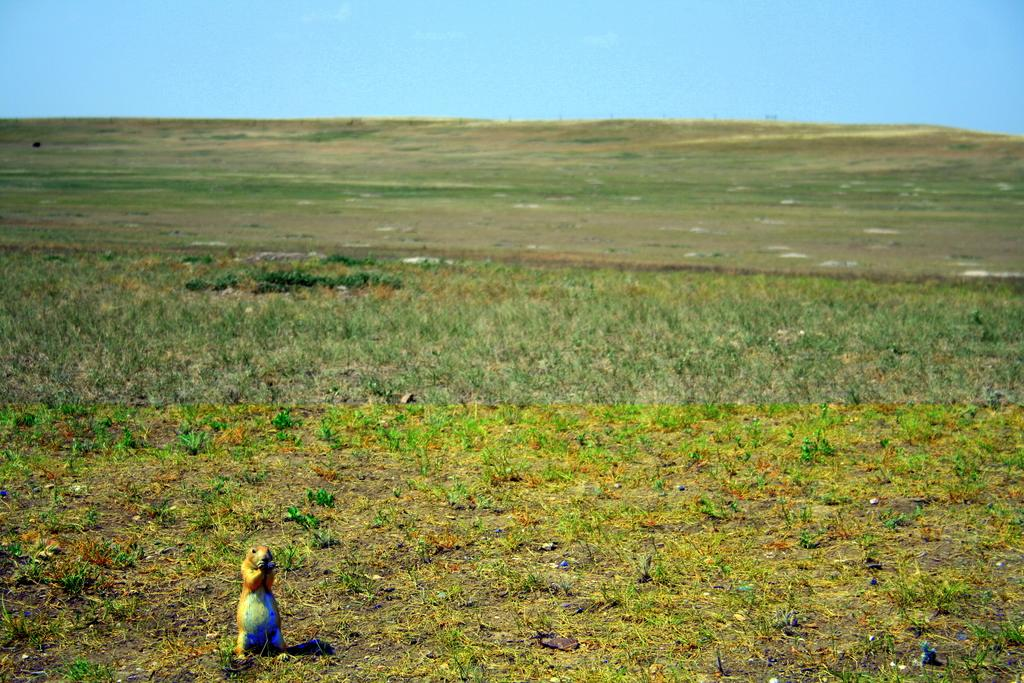What animal is present in the image? There is a squirrel in the image. What colors can be seen on the squirrel? The squirrel has brown and blue coloring. What type of vegetation is visible in the background of the image? There is grass in the background of the image. What is the color of the grass? The grass is green. What part of the natural environment is visible in the background of the image? The sky is visible in the background of the image. What is the color of the sky? The sky is blue. What type of toys can be seen in the image? There are no toys present in the image; it features a squirrel with brown and blue coloring, grass, and a blue sky. What subject is the squirrel teaching in the image? There is no indication in the image that the squirrel is teaching any subject. 